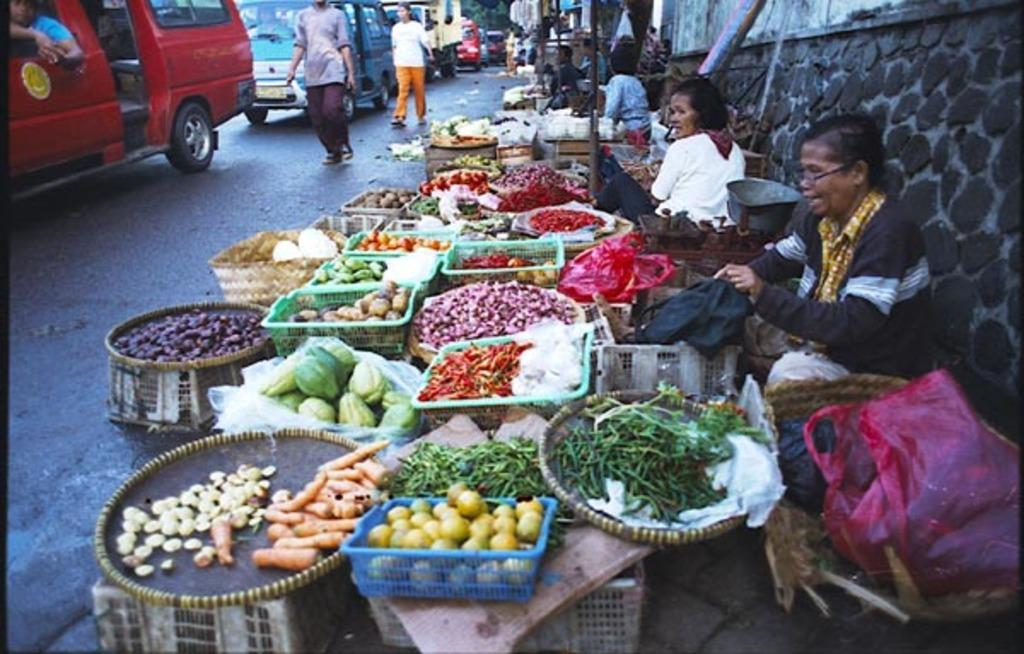What can be seen on the road in the image? There are vehicles and people on the road in the image. What else is present in the image besides the road? There are vegetables, baskets, and a wall visible in the image. Who is near the vegetables and baskets? There are people near the vegetables and baskets in the image. What can be seen in the background of the image? Trees are visible in the background of the image. How many rakes are being used by the people near the vegetables and baskets? There are no rakes present in the image; people near the vegetables and baskets are not using any rakes. What color are the eyes of the vegetables in the image? Vegetables do not have eyes, so this question cannot be answered. 